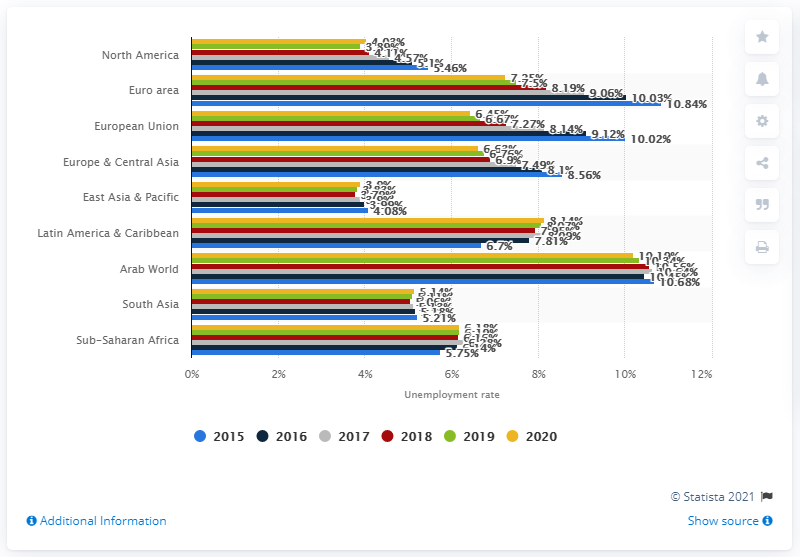Draw attention to some important aspects in this diagram. The unemployment rate in the Arab world in 2020 was 10.19%. 